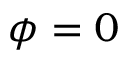<formula> <loc_0><loc_0><loc_500><loc_500>\phi = 0</formula> 